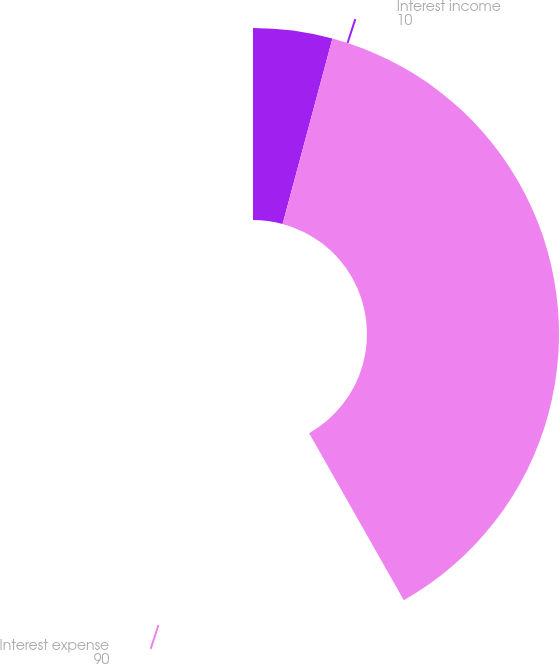Convert chart to OTSL. <chart><loc_0><loc_0><loc_500><loc_500><pie_chart><fcel>Interest income<fcel>Interest expense<nl><fcel>10.0%<fcel>90.0%<nl></chart> 